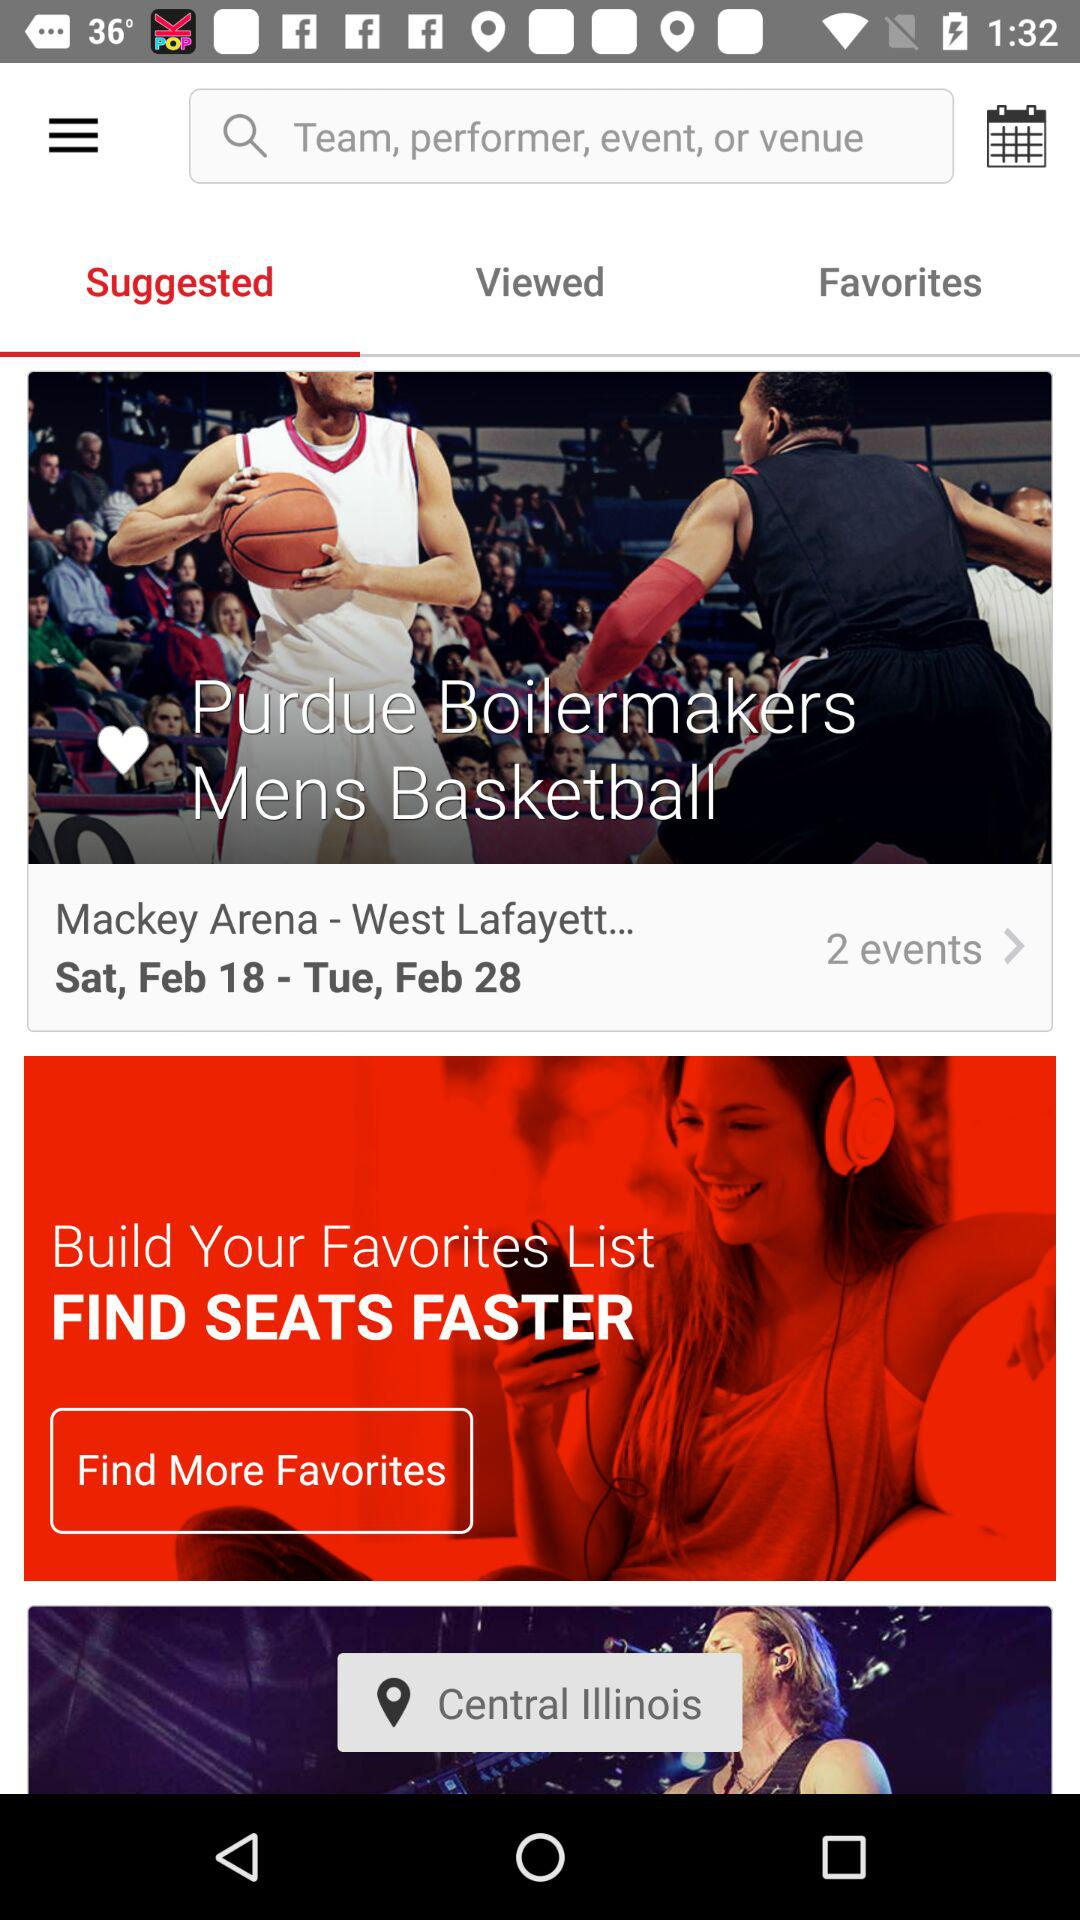How many events are there? There are two events. 